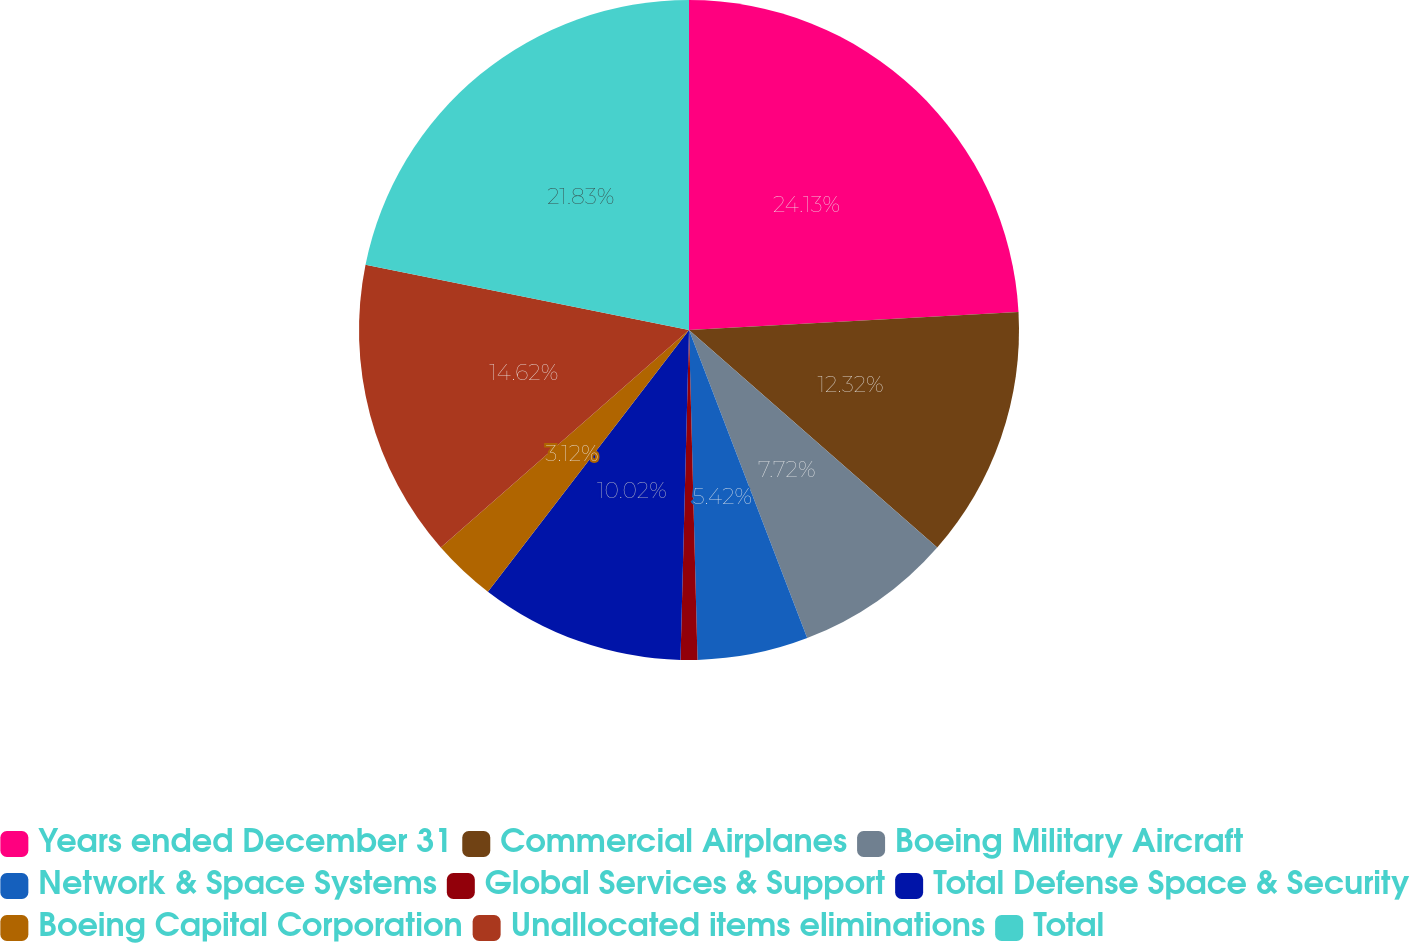<chart> <loc_0><loc_0><loc_500><loc_500><pie_chart><fcel>Years ended December 31<fcel>Commercial Airplanes<fcel>Boeing Military Aircraft<fcel>Network & Space Systems<fcel>Global Services & Support<fcel>Total Defense Space & Security<fcel>Boeing Capital Corporation<fcel>Unallocated items eliminations<fcel>Total<nl><fcel>24.13%<fcel>12.32%<fcel>7.72%<fcel>5.42%<fcel>0.82%<fcel>10.02%<fcel>3.12%<fcel>14.62%<fcel>21.83%<nl></chart> 